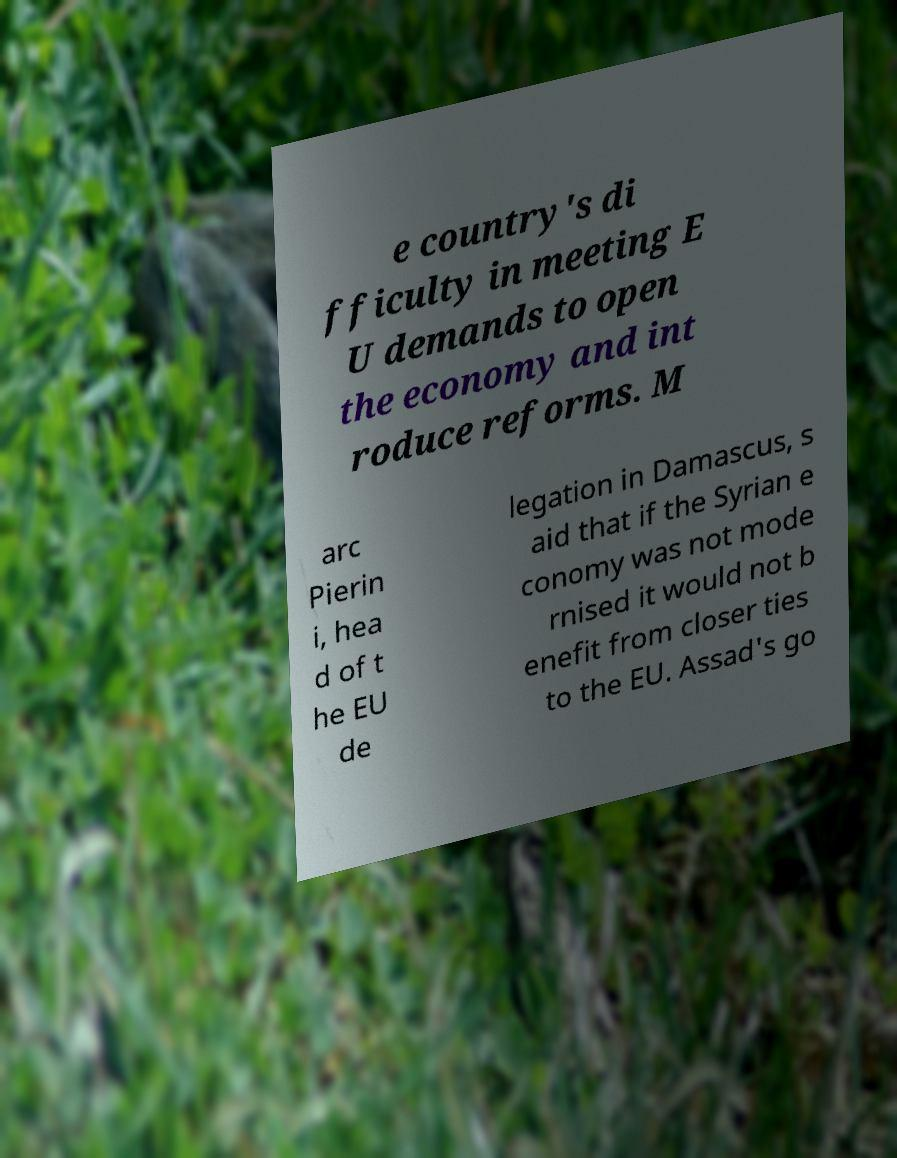Could you assist in decoding the text presented in this image and type it out clearly? e country's di fficulty in meeting E U demands to open the economy and int roduce reforms. M arc Pierin i, hea d of t he EU de legation in Damascus, s aid that if the Syrian e conomy was not mode rnised it would not b enefit from closer ties to the EU. Assad's go 